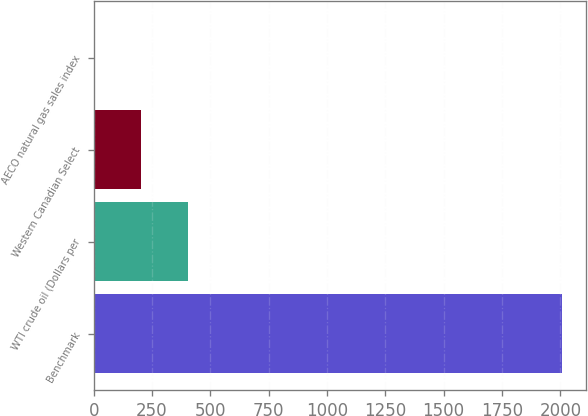<chart> <loc_0><loc_0><loc_500><loc_500><bar_chart><fcel>Benchmark<fcel>WTI crude oil (Dollars per<fcel>Western Canadian Select<fcel>AECO natural gas sales index<nl><fcel>2009<fcel>404.59<fcel>204.04<fcel>3.49<nl></chart> 